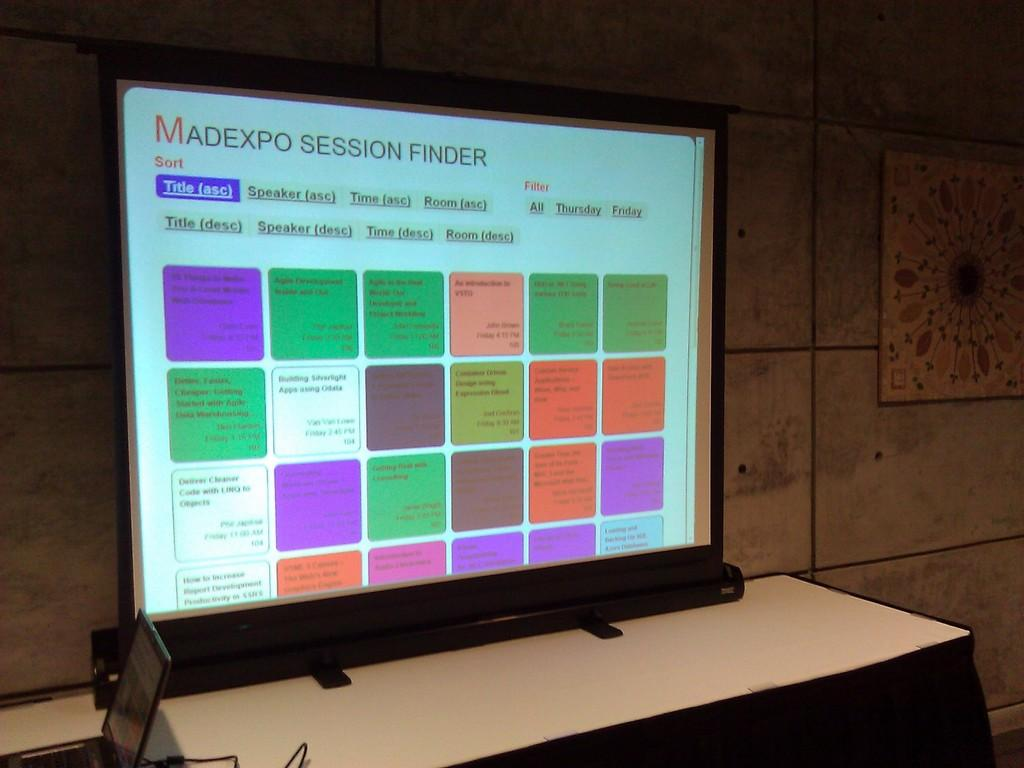Provide a one-sentence caption for the provided image. A large display monitor shows us a Madexp Session finder, a guide to the events that will be happening. 